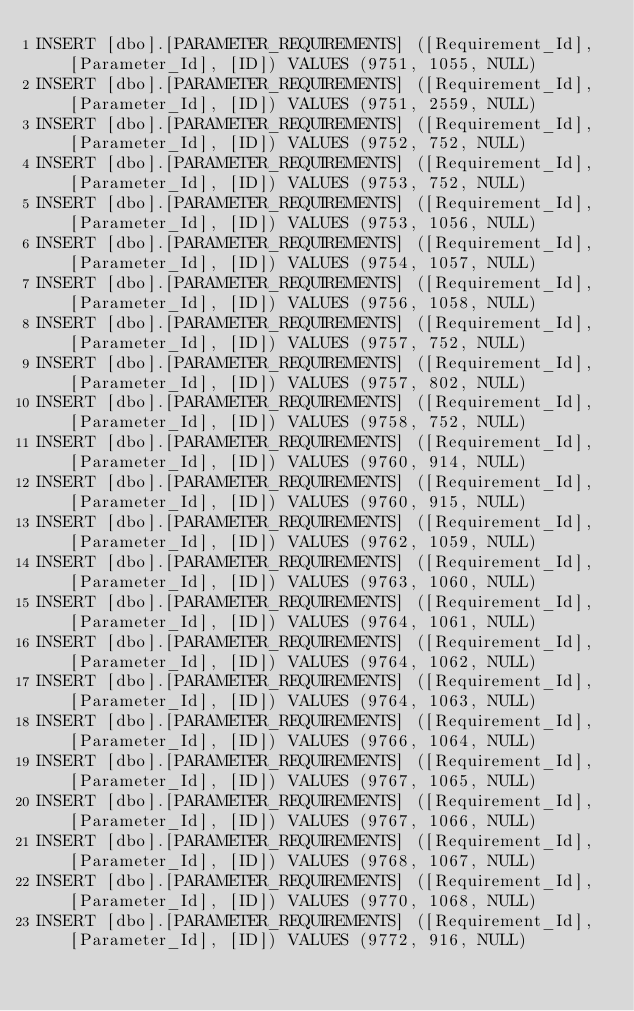Convert code to text. <code><loc_0><loc_0><loc_500><loc_500><_SQL_>INSERT [dbo].[PARAMETER_REQUIREMENTS] ([Requirement_Id], [Parameter_Id], [ID]) VALUES (9751, 1055, NULL)
INSERT [dbo].[PARAMETER_REQUIREMENTS] ([Requirement_Id], [Parameter_Id], [ID]) VALUES (9751, 2559, NULL)
INSERT [dbo].[PARAMETER_REQUIREMENTS] ([Requirement_Id], [Parameter_Id], [ID]) VALUES (9752, 752, NULL)
INSERT [dbo].[PARAMETER_REQUIREMENTS] ([Requirement_Id], [Parameter_Id], [ID]) VALUES (9753, 752, NULL)
INSERT [dbo].[PARAMETER_REQUIREMENTS] ([Requirement_Id], [Parameter_Id], [ID]) VALUES (9753, 1056, NULL)
INSERT [dbo].[PARAMETER_REQUIREMENTS] ([Requirement_Id], [Parameter_Id], [ID]) VALUES (9754, 1057, NULL)
INSERT [dbo].[PARAMETER_REQUIREMENTS] ([Requirement_Id], [Parameter_Id], [ID]) VALUES (9756, 1058, NULL)
INSERT [dbo].[PARAMETER_REQUIREMENTS] ([Requirement_Id], [Parameter_Id], [ID]) VALUES (9757, 752, NULL)
INSERT [dbo].[PARAMETER_REQUIREMENTS] ([Requirement_Id], [Parameter_Id], [ID]) VALUES (9757, 802, NULL)
INSERT [dbo].[PARAMETER_REQUIREMENTS] ([Requirement_Id], [Parameter_Id], [ID]) VALUES (9758, 752, NULL)
INSERT [dbo].[PARAMETER_REQUIREMENTS] ([Requirement_Id], [Parameter_Id], [ID]) VALUES (9760, 914, NULL)
INSERT [dbo].[PARAMETER_REQUIREMENTS] ([Requirement_Id], [Parameter_Id], [ID]) VALUES (9760, 915, NULL)
INSERT [dbo].[PARAMETER_REQUIREMENTS] ([Requirement_Id], [Parameter_Id], [ID]) VALUES (9762, 1059, NULL)
INSERT [dbo].[PARAMETER_REQUIREMENTS] ([Requirement_Id], [Parameter_Id], [ID]) VALUES (9763, 1060, NULL)
INSERT [dbo].[PARAMETER_REQUIREMENTS] ([Requirement_Id], [Parameter_Id], [ID]) VALUES (9764, 1061, NULL)
INSERT [dbo].[PARAMETER_REQUIREMENTS] ([Requirement_Id], [Parameter_Id], [ID]) VALUES (9764, 1062, NULL)
INSERT [dbo].[PARAMETER_REQUIREMENTS] ([Requirement_Id], [Parameter_Id], [ID]) VALUES (9764, 1063, NULL)
INSERT [dbo].[PARAMETER_REQUIREMENTS] ([Requirement_Id], [Parameter_Id], [ID]) VALUES (9766, 1064, NULL)
INSERT [dbo].[PARAMETER_REQUIREMENTS] ([Requirement_Id], [Parameter_Id], [ID]) VALUES (9767, 1065, NULL)
INSERT [dbo].[PARAMETER_REQUIREMENTS] ([Requirement_Id], [Parameter_Id], [ID]) VALUES (9767, 1066, NULL)
INSERT [dbo].[PARAMETER_REQUIREMENTS] ([Requirement_Id], [Parameter_Id], [ID]) VALUES (9768, 1067, NULL)
INSERT [dbo].[PARAMETER_REQUIREMENTS] ([Requirement_Id], [Parameter_Id], [ID]) VALUES (9770, 1068, NULL)
INSERT [dbo].[PARAMETER_REQUIREMENTS] ([Requirement_Id], [Parameter_Id], [ID]) VALUES (9772, 916, NULL)</code> 